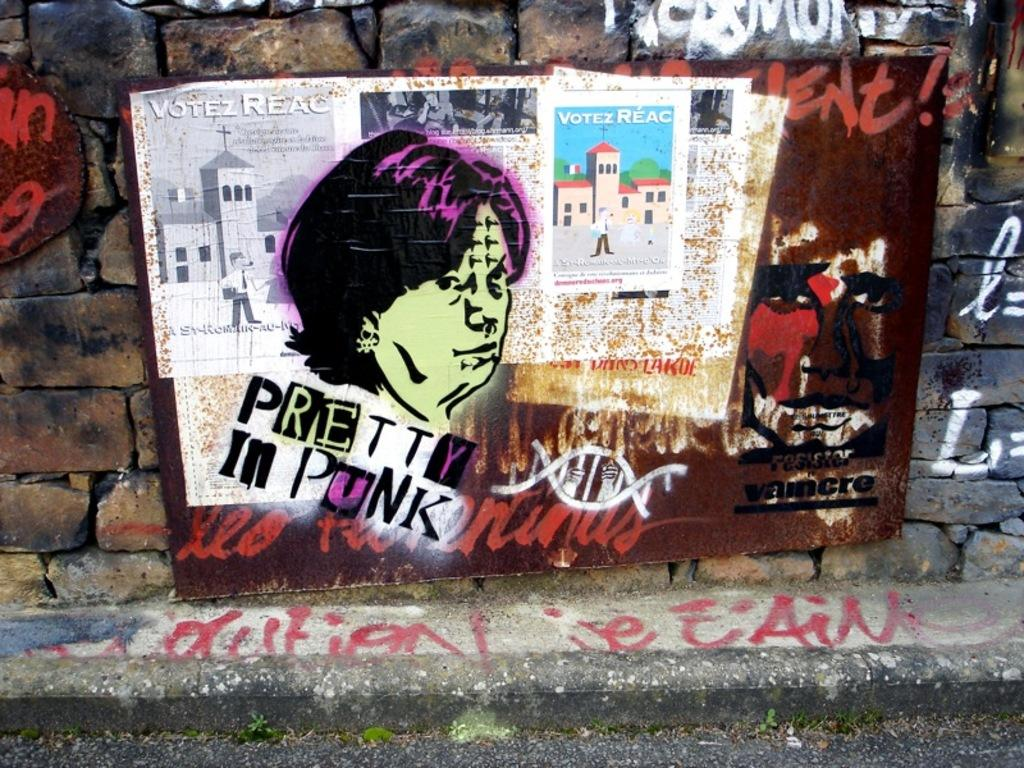<image>
Write a terse but informative summary of the picture. A wall of graffiti that says pretty in punk 